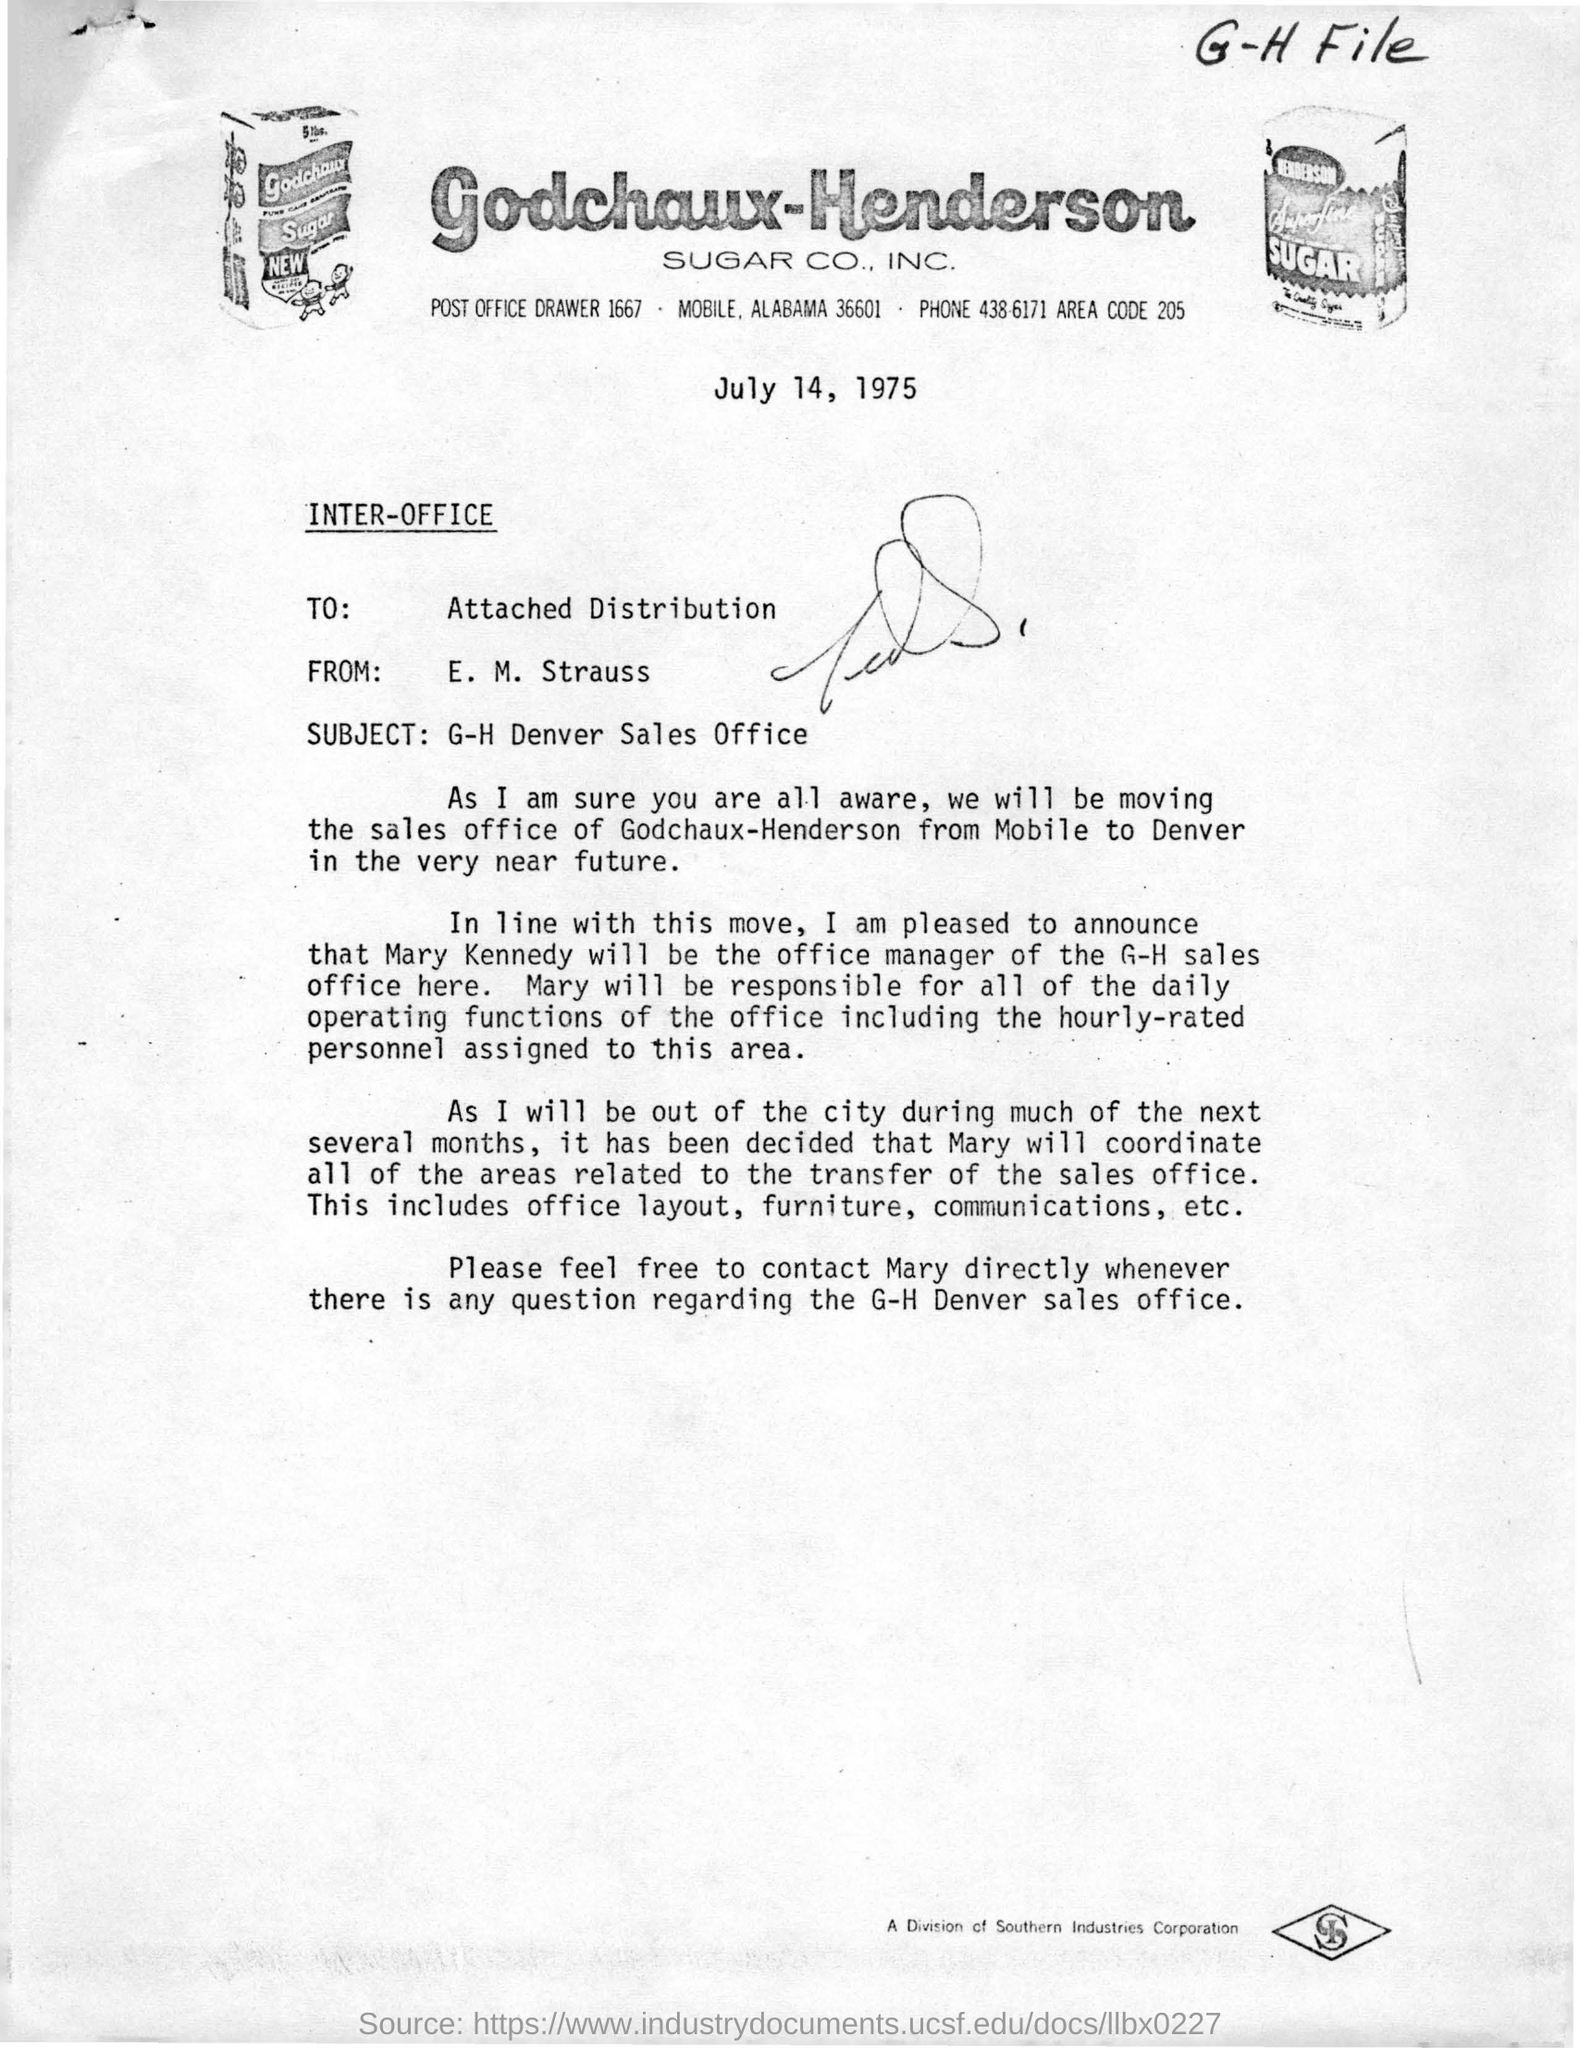What is the area code for Godchaux-Henderson Sugar CO, INC.?
Ensure brevity in your answer.  205. Who is the memorandum from?
Give a very brief answer. E. M. Strauss. Where will the sales office of Godchaux-Henderson be moving to?
Offer a very short reply. Denver. Who will be the office manager of the G-H sales office?
Your answer should be very brief. Mary Kennedy. 